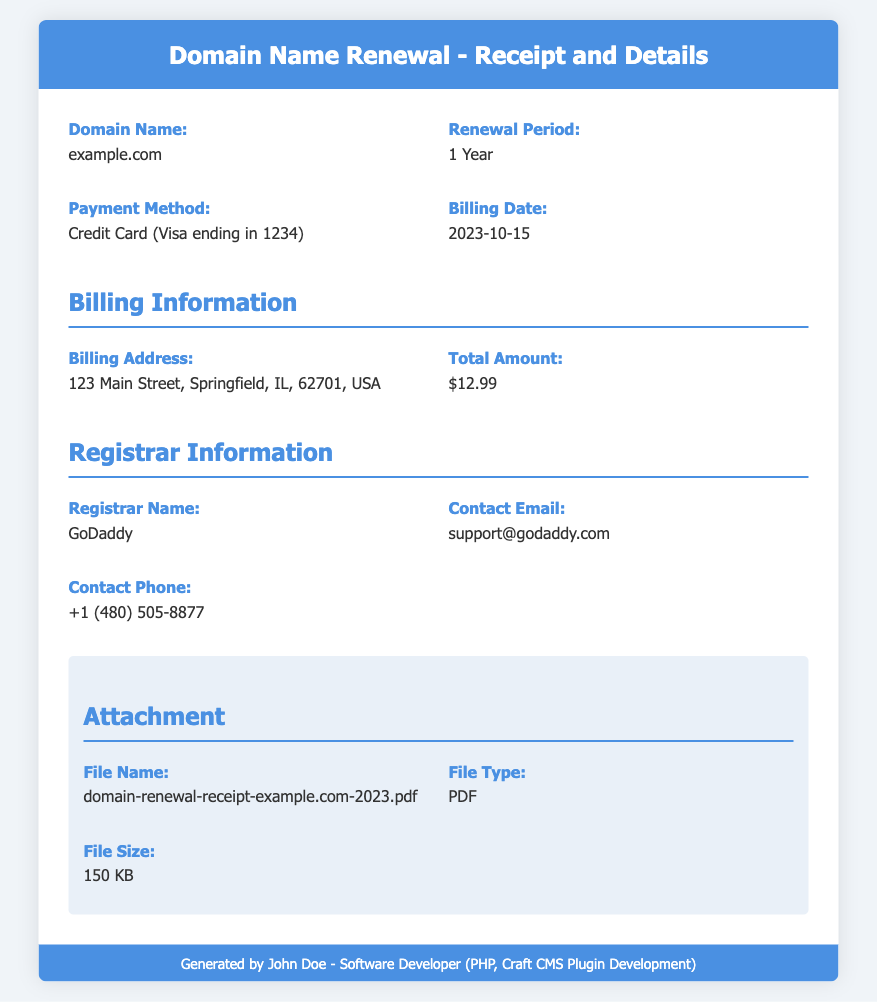What is the domain name? The domain name listed in the document is found in the first information item, which is "example.com".
Answer: example.com What is the renewal period? The renewal period is detailed in the second information item, which states "1 Year".
Answer: 1 Year What is the payment method used? The payment method is specified in the third information item, mentioning "Credit Card (Visa ending in 1234)".
Answer: Credit Card (Visa ending in 1234) When was the billing date? The billing date can be found in the fourth information item, which specifies "2023-10-15".
Answer: 2023-10-15 What is the total amount charged? The total amount is indicated in the billing information section as "$12.99".
Answer: $12.99 Who is the registrar? The registrar's name is highlighted in the registrar information section as "GoDaddy".
Answer: GoDaddy What type of file is attached? The type of the attached file is listed in the attachment section, which states "PDF".
Answer: PDF What is the file name of the receipt? The file name is provided in the attachment section as "domain-renewal-receipt-example.com-2023.pdf".
Answer: domain-renewal-receipt-example.com-2023.pdf What is the contact email for the registrar? The contact email is mentioned in the registrar information as "support@godaddy.com".
Answer: support@godaddy.com How much does the renewal cost? The renewal cost is found under the billing information section as "$12.99".
Answer: $12.99 